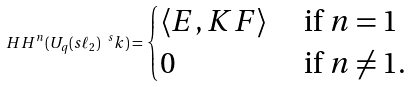<formula> <loc_0><loc_0><loc_500><loc_500>H H ^ { n } ( U _ { q } ( s \ell _ { 2 } ) ^ { \ s } k ) = \begin{cases} \langle E , K F \rangle & \text { if } n = 1 \\ 0 & \text { if } n \neq 1 . \end{cases}</formula> 